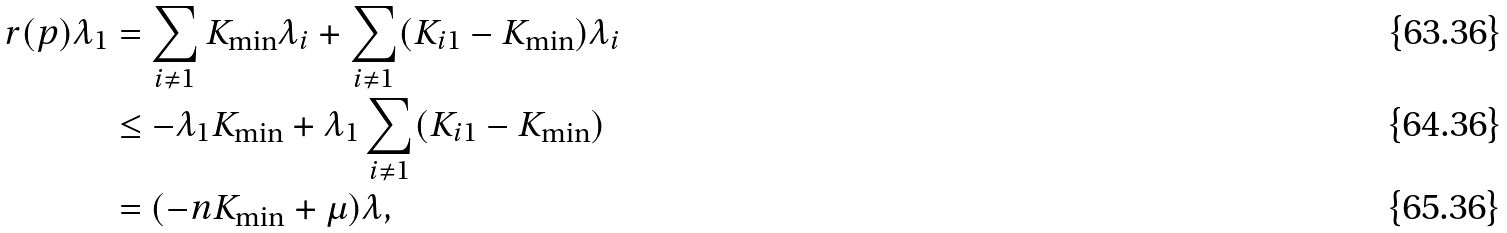<formula> <loc_0><loc_0><loc_500><loc_500>r ( p ) \lambda _ { 1 } & = \sum _ { i \neq 1 } K _ { \min } \lambda _ { i } + \sum _ { i \neq 1 } ( K _ { i 1 } - K _ { \min } ) \lambda _ { i } \\ & \leq - \lambda _ { 1 } K _ { \min } + \lambda _ { 1 } \sum _ { i \neq 1 } ( K _ { i 1 } - K _ { \min } ) \\ & = ( - n K _ { \min } + \mu ) \lambda ,</formula> 